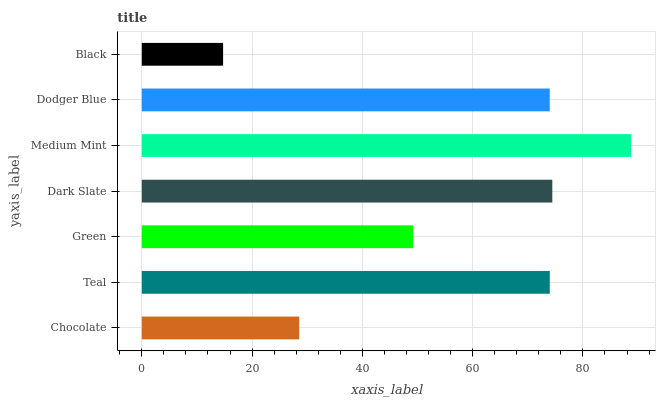Is Black the minimum?
Answer yes or no. Yes. Is Medium Mint the maximum?
Answer yes or no. Yes. Is Teal the minimum?
Answer yes or no. No. Is Teal the maximum?
Answer yes or no. No. Is Teal greater than Chocolate?
Answer yes or no. Yes. Is Chocolate less than Teal?
Answer yes or no. Yes. Is Chocolate greater than Teal?
Answer yes or no. No. Is Teal less than Chocolate?
Answer yes or no. No. Is Dodger Blue the high median?
Answer yes or no. Yes. Is Dodger Blue the low median?
Answer yes or no. Yes. Is Black the high median?
Answer yes or no. No. Is Dark Slate the low median?
Answer yes or no. No. 